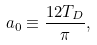Convert formula to latex. <formula><loc_0><loc_0><loc_500><loc_500>a _ { 0 } \equiv \frac { 1 2 T _ { D } } { \pi } ,</formula> 